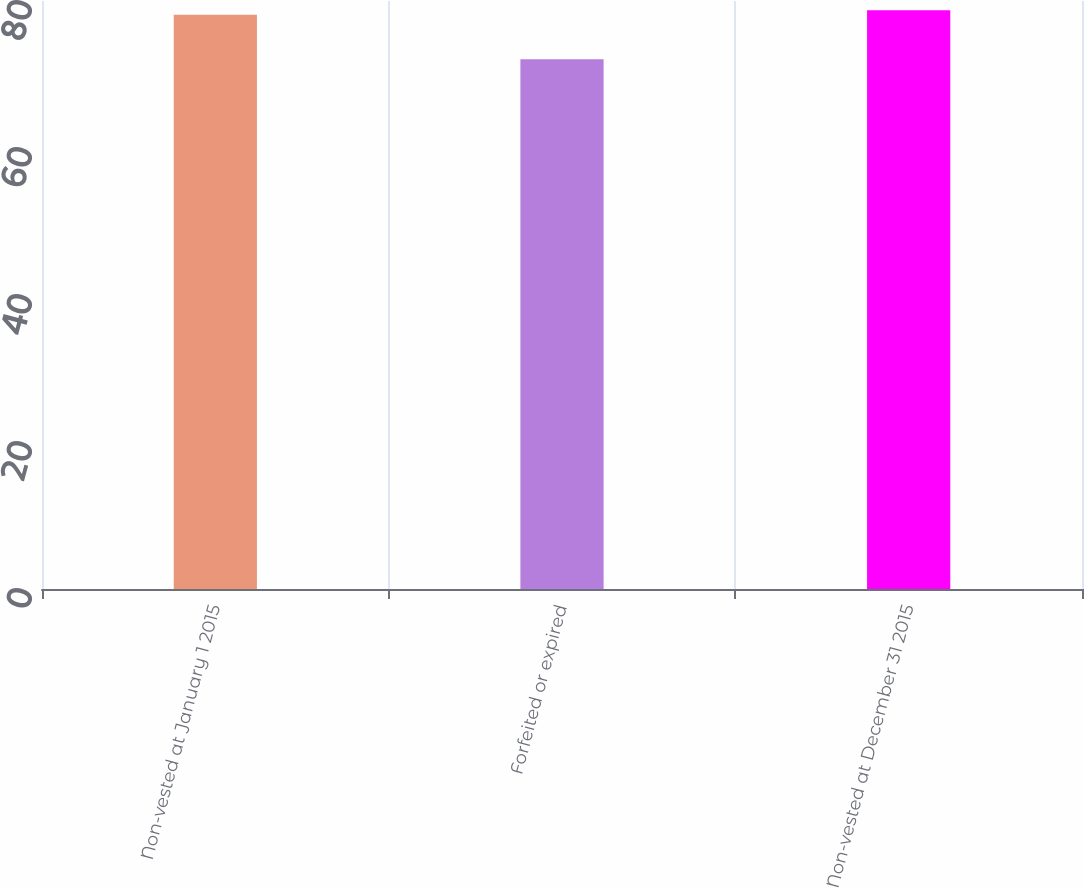Convert chart to OTSL. <chart><loc_0><loc_0><loc_500><loc_500><bar_chart><fcel>Non-vested at January 1 2015<fcel>Forfeited or expired<fcel>Non-vested at December 31 2015<nl><fcel>78.13<fcel>72.09<fcel>78.74<nl></chart> 